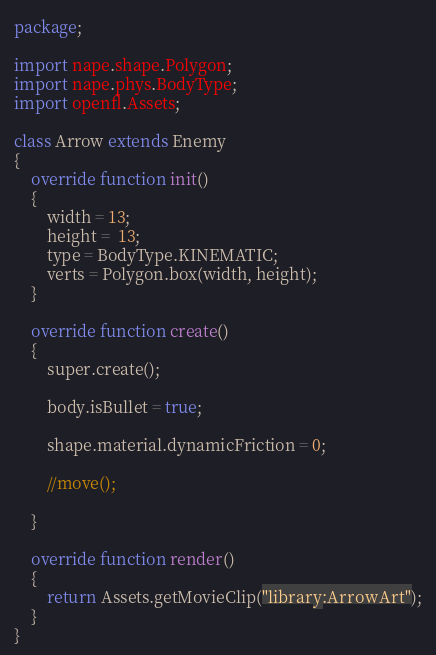<code> <loc_0><loc_0><loc_500><loc_500><_Haxe_>package;

import nape.shape.Polygon;
import nape.phys.BodyType;
import openfl.Assets;

class Arrow extends Enemy
{
    override function init()
    {
        width = 13;
        height =  13;
		type = BodyType.KINEMATIC;
		verts = Polygon.box(width, height);
    }

    override function create()
    {
        super.create();

        body.isBullet = true;

		shape.material.dynamicFriction = 0;

        //move();

    }

    override function render()
    {
        return Assets.getMovieClip("library:ArrowArt");
    }
}
</code> 